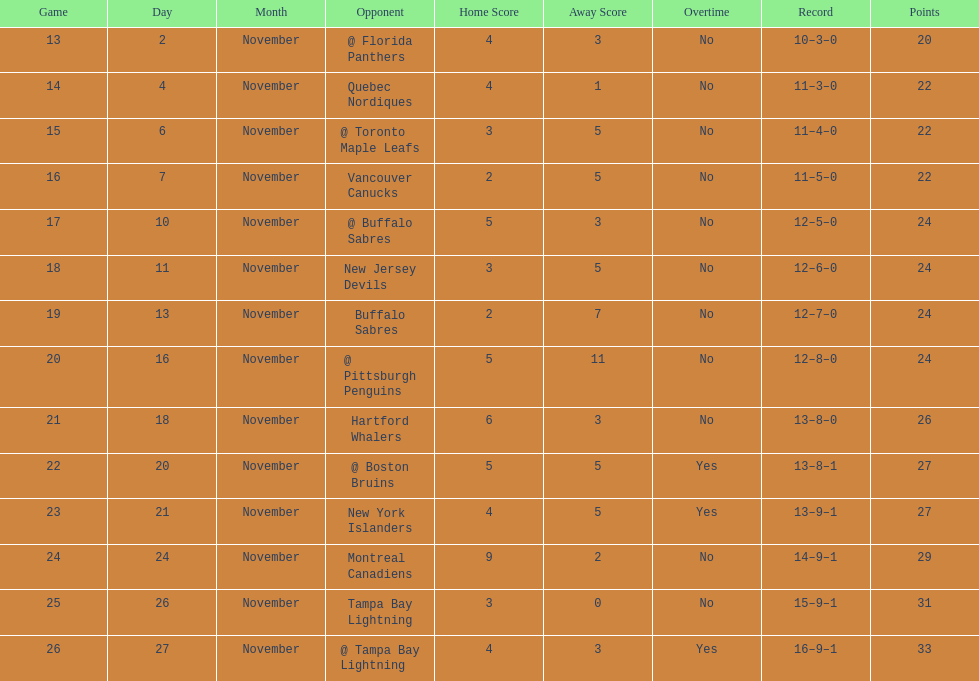Who had the most assists on the 1993-1994 flyers? Mark Recchi. 